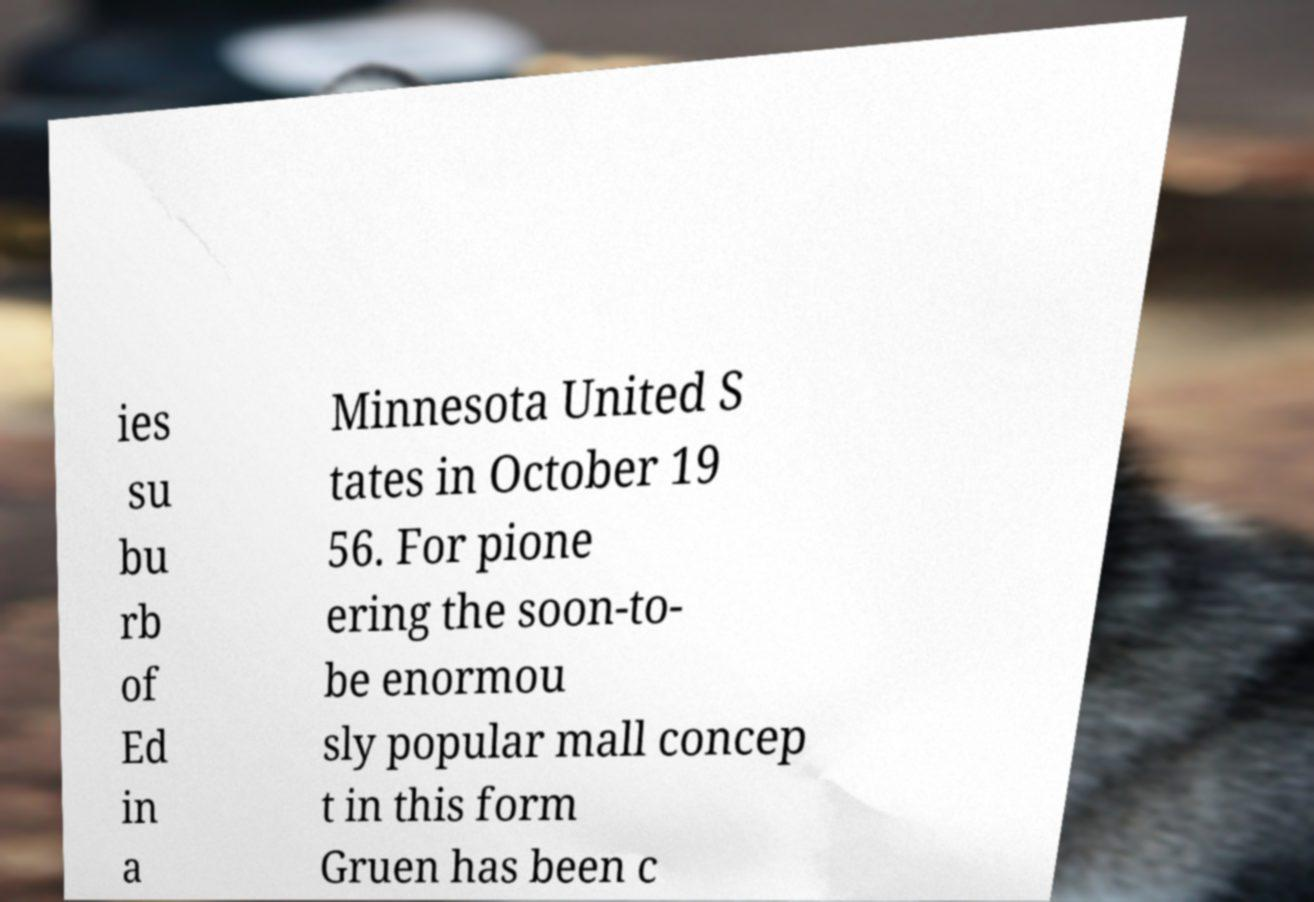Please read and relay the text visible in this image. What does it say? ies su bu rb of Ed in a Minnesota United S tates in October 19 56. For pione ering the soon-to- be enormou sly popular mall concep t in this form Gruen has been c 